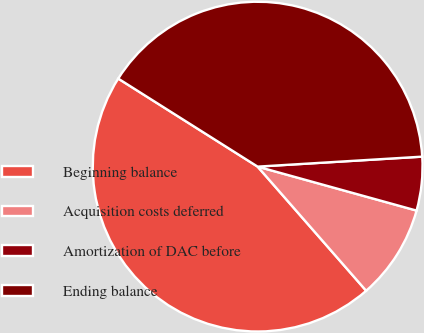<chart> <loc_0><loc_0><loc_500><loc_500><pie_chart><fcel>Beginning balance<fcel>Acquisition costs deferred<fcel>Amortization of DAC before<fcel>Ending balance<nl><fcel>45.4%<fcel>9.27%<fcel>5.26%<fcel>40.07%<nl></chart> 